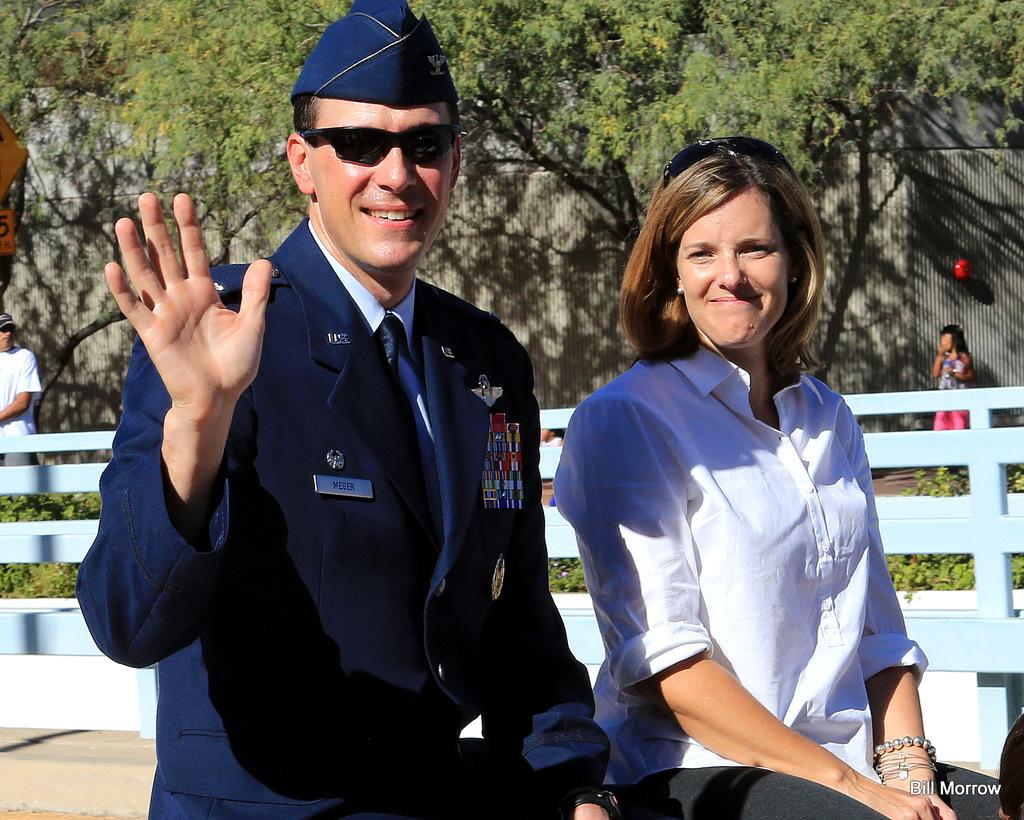How many people are present in the image? There are two people in the image. What is located behind the two people? There is a fence behind the two people. What can be seen beyond the fence? There are trees visible behind the fence. Are there any other people in the image? Yes, there are two other people behind the trees and fence. What type of kitty is sitting on the suit in the image? There is no kitty or suit present in the image. 